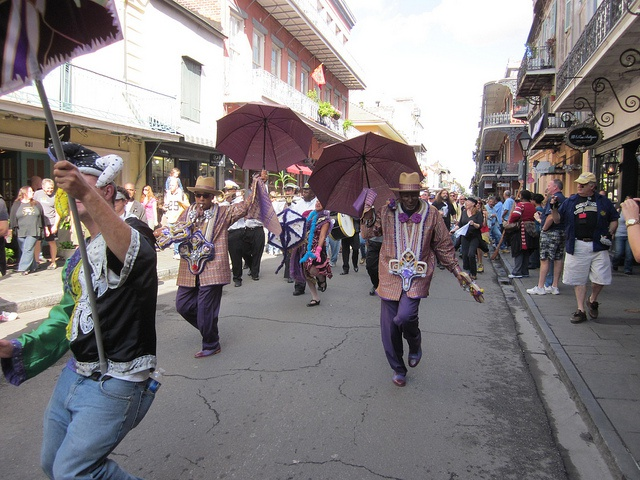Describe the objects in this image and their specific colors. I can see people in black and gray tones, people in black, gray, darkgray, and white tones, people in black, gray, and darkgray tones, umbrella in black and gray tones, and people in black, gray, and darkgray tones in this image. 